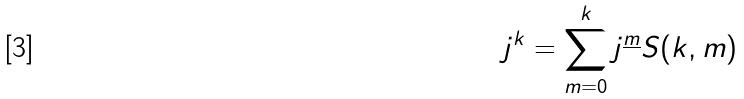Convert formula to latex. <formula><loc_0><loc_0><loc_500><loc_500>j ^ { k } = \sum _ { m = 0 } ^ { k } j ^ { \underline { m } } S ( k , m )</formula> 